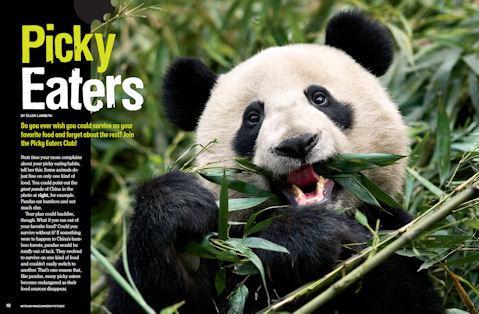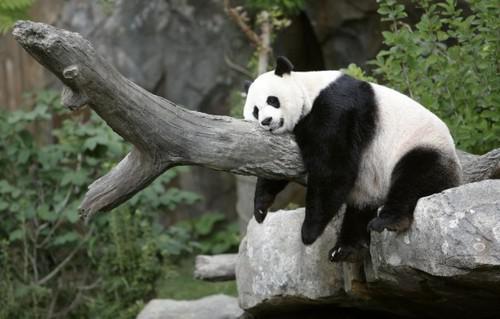The first image is the image on the left, the second image is the image on the right. For the images displayed, is the sentence "One image features one forward-facing panda chewing green leaves, with the paw on the left raised and curled over." factually correct? Answer yes or no. Yes. The first image is the image on the left, the second image is the image on the right. Given the left and right images, does the statement "There are two pandas eating." hold true? Answer yes or no. No. 